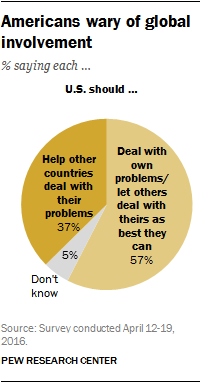Specify some key components in this picture. A recent survey indicates that 37% of people believe that the United States should help other countries deal with their problems. If one adds the two smallest segments of a larger segment and then subtracts the result from the larger segment, what is the final result? 